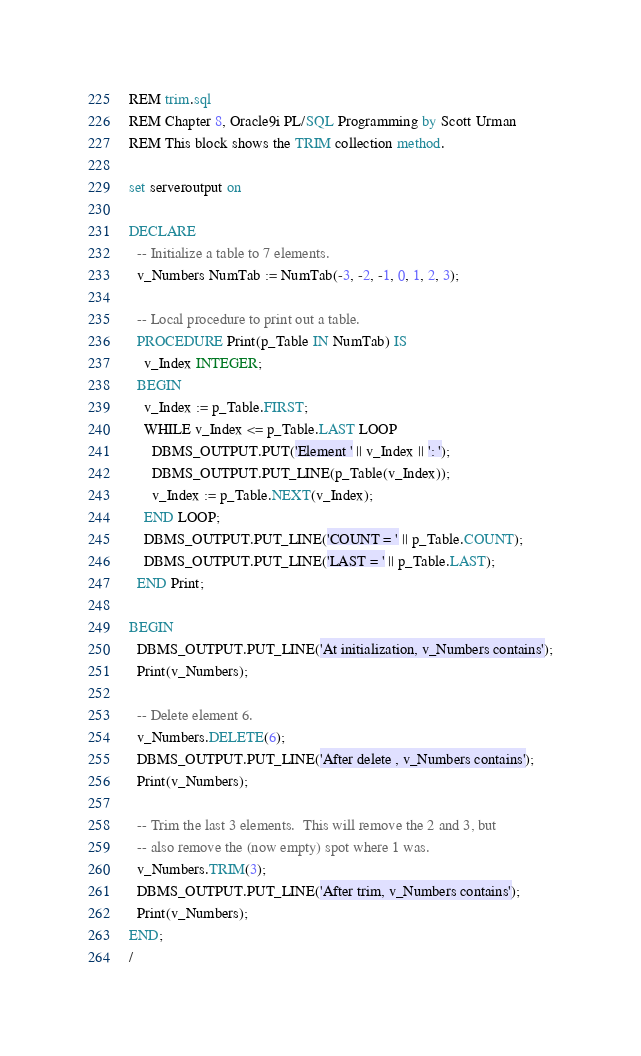Convert code to text. <code><loc_0><loc_0><loc_500><loc_500><_SQL_>REM trim.sql
REM Chapter 8, Oracle9i PL/SQL Programming by Scott Urman
REM This block shows the TRIM collection method.

set serveroutput on

DECLARE
  -- Initialize a table to 7 elements.
  v_Numbers NumTab := NumTab(-3, -2, -1, 0, 1, 2, 3);

  -- Local procedure to print out a table.
  PROCEDURE Print(p_Table IN NumTab) IS
    v_Index INTEGER;
  BEGIN
    v_Index := p_Table.FIRST;
    WHILE v_Index <= p_Table.LAST LOOP
      DBMS_OUTPUT.PUT('Element ' || v_Index || ': ');
      DBMS_OUTPUT.PUT_LINE(p_Table(v_Index));
      v_Index := p_Table.NEXT(v_Index);
    END LOOP;
    DBMS_OUTPUT.PUT_LINE('COUNT = ' || p_Table.COUNT);
    DBMS_OUTPUT.PUT_LINE('LAST = ' || p_Table.LAST);
  END Print;

BEGIN
  DBMS_OUTPUT.PUT_LINE('At initialization, v_Numbers contains');
  Print(v_Numbers);

  -- Delete element 6.
  v_Numbers.DELETE(6);
  DBMS_OUTPUT.PUT_LINE('After delete , v_Numbers contains');
  Print(v_Numbers);

  -- Trim the last 3 elements.  This will remove the 2 and 3, but
  -- also remove the (now empty) spot where 1 was.
  v_Numbers.TRIM(3);
  DBMS_OUTPUT.PUT_LINE('After trim, v_Numbers contains');
  Print(v_Numbers);
END;
/
</code> 